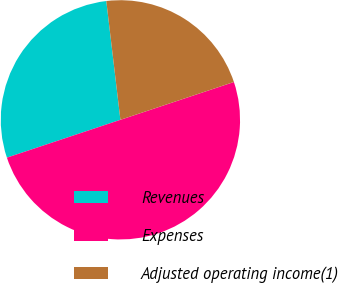Convert chart to OTSL. <chart><loc_0><loc_0><loc_500><loc_500><pie_chart><fcel>Revenues<fcel>Expenses<fcel>Adjusted operating income(1)<nl><fcel>28.24%<fcel>50.0%<fcel>21.76%<nl></chart> 